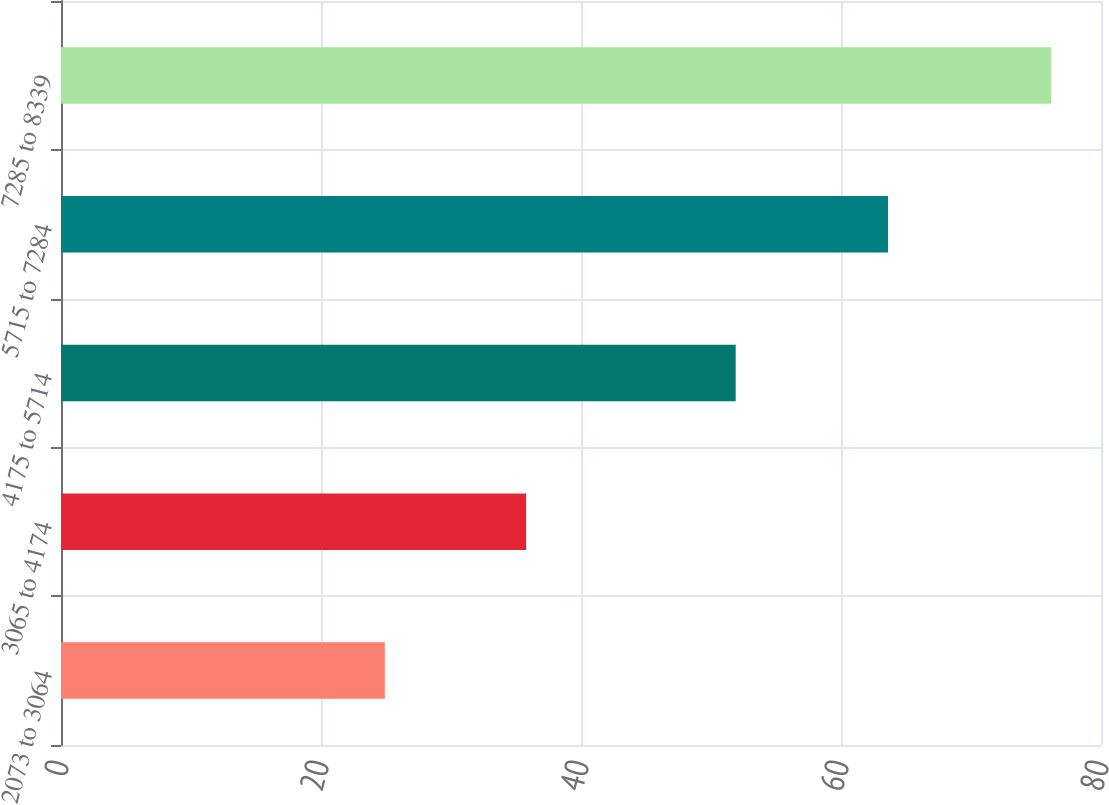Convert chart to OTSL. <chart><loc_0><loc_0><loc_500><loc_500><bar_chart><fcel>2073 to 3064<fcel>3065 to 4174<fcel>4175 to 5714<fcel>5715 to 7284<fcel>7285 to 8339<nl><fcel>24.91<fcel>35.78<fcel>51.9<fcel>63.62<fcel>76.16<nl></chart> 